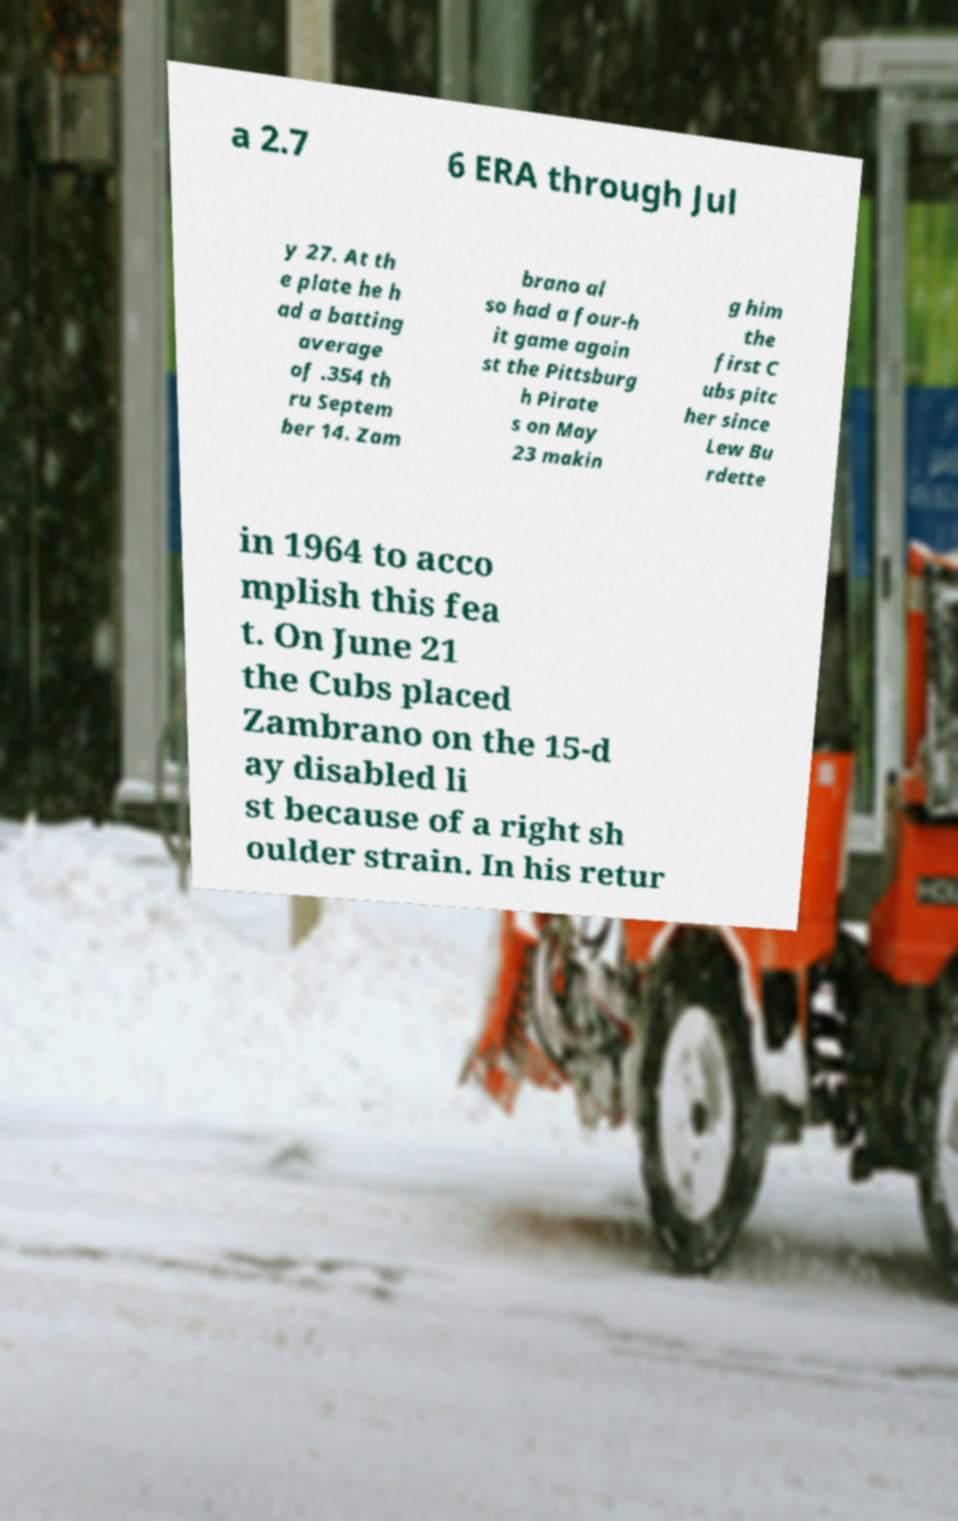Please identify and transcribe the text found in this image. a 2.7 6 ERA through Jul y 27. At th e plate he h ad a batting average of .354 th ru Septem ber 14. Zam brano al so had a four-h it game again st the Pittsburg h Pirate s on May 23 makin g him the first C ubs pitc her since Lew Bu rdette in 1964 to acco mplish this fea t. On June 21 the Cubs placed Zambrano on the 15-d ay disabled li st because of a right sh oulder strain. In his retur 